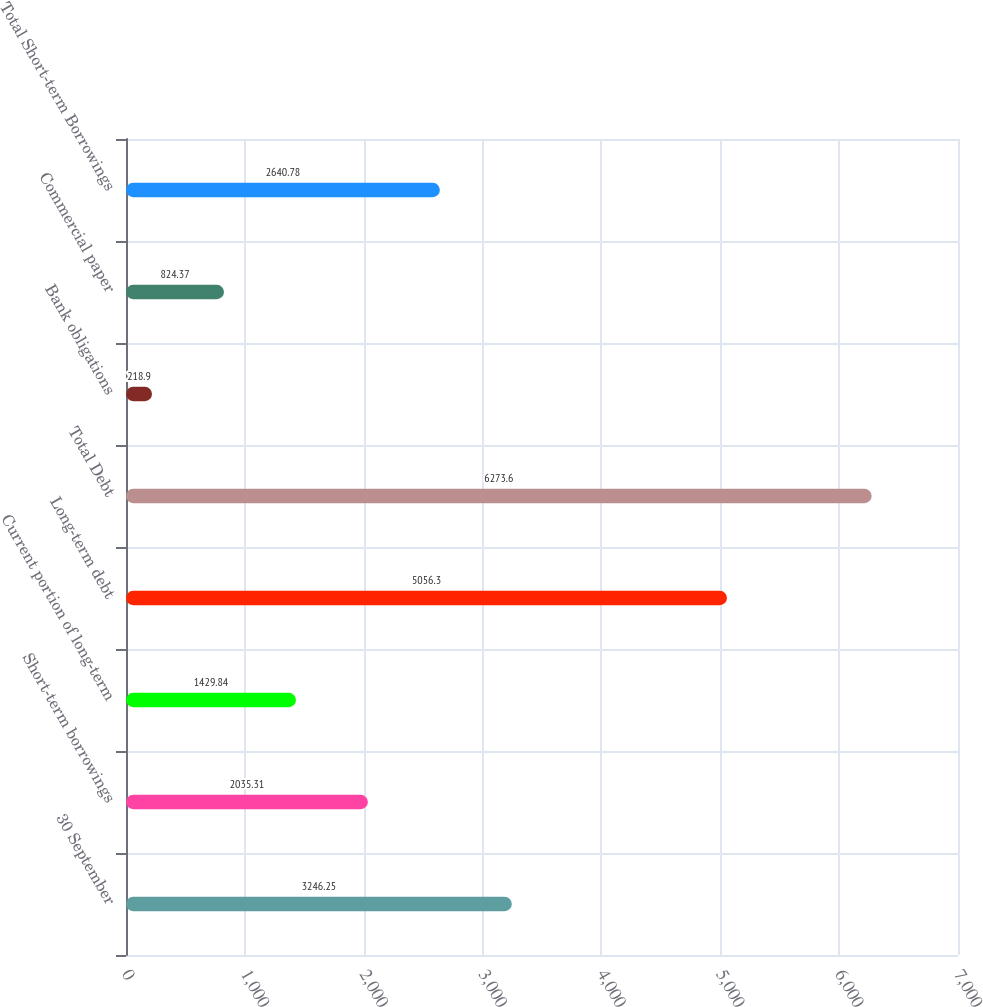<chart> <loc_0><loc_0><loc_500><loc_500><bar_chart><fcel>30 September<fcel>Short-term borrowings<fcel>Current portion of long-term<fcel>Long-term debt<fcel>Total Debt<fcel>Bank obligations<fcel>Commercial paper<fcel>Total Short-term Borrowings<nl><fcel>3246.25<fcel>2035.31<fcel>1429.84<fcel>5056.3<fcel>6273.6<fcel>218.9<fcel>824.37<fcel>2640.78<nl></chart> 